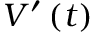<formula> <loc_0><loc_0><loc_500><loc_500>V ^ { \prime } \left ( t \right )</formula> 